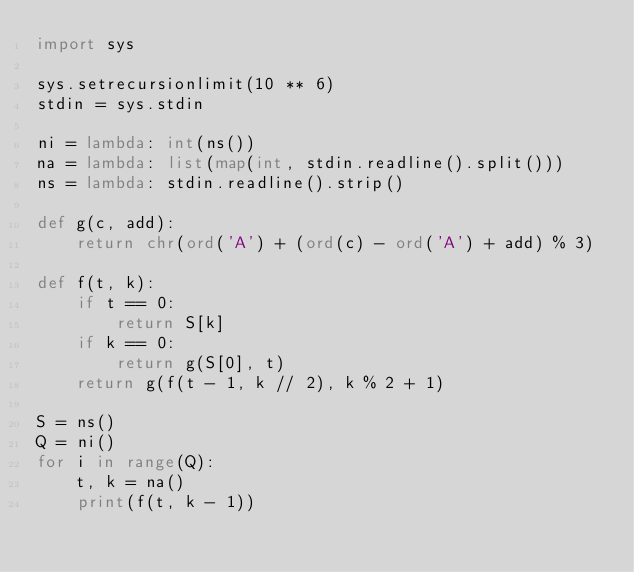Convert code to text. <code><loc_0><loc_0><loc_500><loc_500><_Python_>import sys

sys.setrecursionlimit(10 ** 6)
stdin = sys.stdin

ni = lambda: int(ns())
na = lambda: list(map(int, stdin.readline().split()))
ns = lambda: stdin.readline().strip()

def g(c, add):
    return chr(ord('A') + (ord(c) - ord('A') + add) % 3)

def f(t, k):
    if t == 0:
        return S[k]
    if k == 0:
        return g(S[0], t)
    return g(f(t - 1, k // 2), k % 2 + 1)

S = ns()
Q = ni()
for i in range(Q):
    t, k = na()
    print(f(t, k - 1))
</code> 